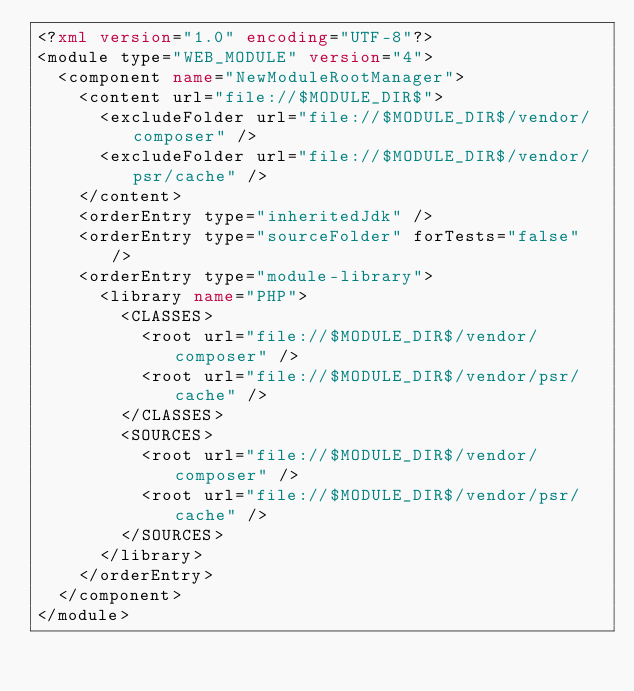Convert code to text. <code><loc_0><loc_0><loc_500><loc_500><_XML_><?xml version="1.0" encoding="UTF-8"?>
<module type="WEB_MODULE" version="4">
  <component name="NewModuleRootManager">
    <content url="file://$MODULE_DIR$">
      <excludeFolder url="file://$MODULE_DIR$/vendor/composer" />
      <excludeFolder url="file://$MODULE_DIR$/vendor/psr/cache" />
    </content>
    <orderEntry type="inheritedJdk" />
    <orderEntry type="sourceFolder" forTests="false" />
    <orderEntry type="module-library">
      <library name="PHP">
        <CLASSES>
          <root url="file://$MODULE_DIR$/vendor/composer" />
          <root url="file://$MODULE_DIR$/vendor/psr/cache" />
        </CLASSES>
        <SOURCES>
          <root url="file://$MODULE_DIR$/vendor/composer" />
          <root url="file://$MODULE_DIR$/vendor/psr/cache" />
        </SOURCES>
      </library>
    </orderEntry>
  </component>
</module></code> 